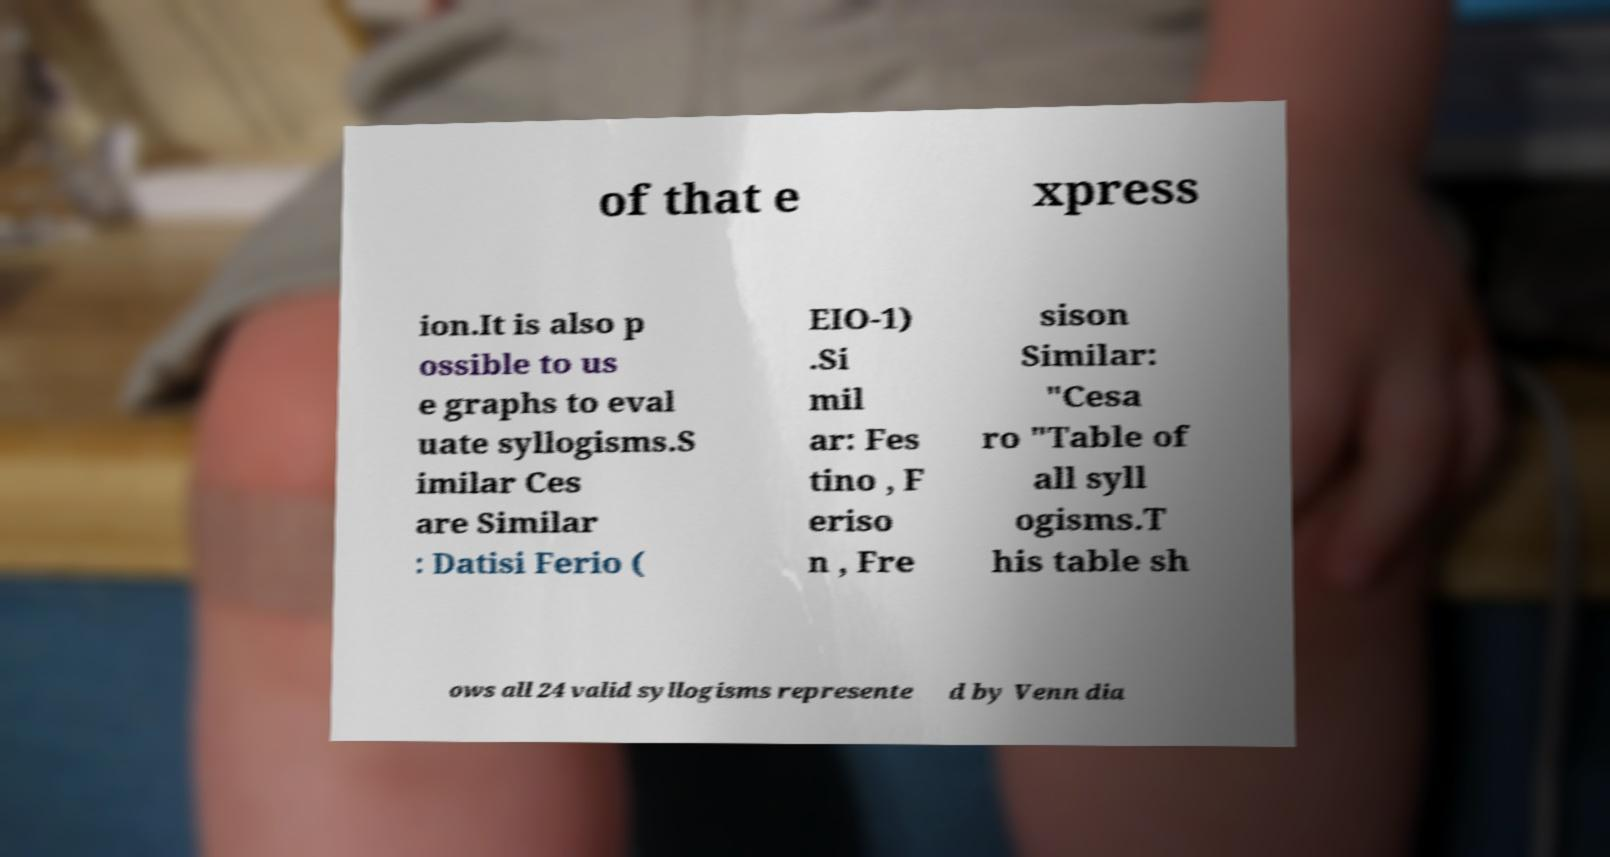Could you assist in decoding the text presented in this image and type it out clearly? of that e xpress ion.It is also p ossible to us e graphs to eval uate syllogisms.S imilar Ces are Similar : Datisi Ferio ( EIO-1) .Si mil ar: Fes tino , F eriso n , Fre sison Similar: "Cesa ro "Table of all syll ogisms.T his table sh ows all 24 valid syllogisms represente d by Venn dia 